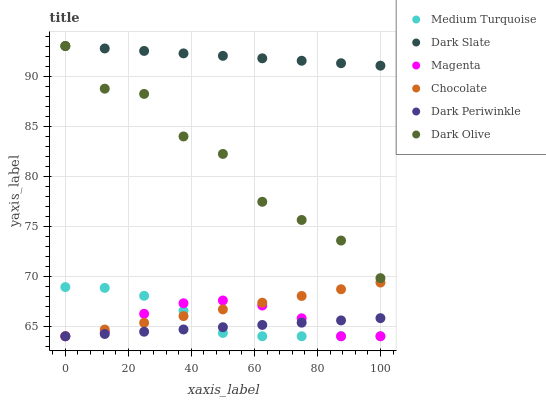Does Dark Periwinkle have the minimum area under the curve?
Answer yes or no. Yes. Does Dark Slate have the maximum area under the curve?
Answer yes or no. Yes. Does Chocolate have the minimum area under the curve?
Answer yes or no. No. Does Chocolate have the maximum area under the curve?
Answer yes or no. No. Is Dark Slate the smoothest?
Answer yes or no. Yes. Is Dark Olive the roughest?
Answer yes or no. Yes. Is Chocolate the smoothest?
Answer yes or no. No. Is Chocolate the roughest?
Answer yes or no. No. Does Chocolate have the lowest value?
Answer yes or no. Yes. Does Dark Slate have the lowest value?
Answer yes or no. No. Does Dark Slate have the highest value?
Answer yes or no. Yes. Does Chocolate have the highest value?
Answer yes or no. No. Is Chocolate less than Dark Olive?
Answer yes or no. Yes. Is Dark Olive greater than Medium Turquoise?
Answer yes or no. Yes. Does Dark Periwinkle intersect Medium Turquoise?
Answer yes or no. Yes. Is Dark Periwinkle less than Medium Turquoise?
Answer yes or no. No. Is Dark Periwinkle greater than Medium Turquoise?
Answer yes or no. No. Does Chocolate intersect Dark Olive?
Answer yes or no. No. 